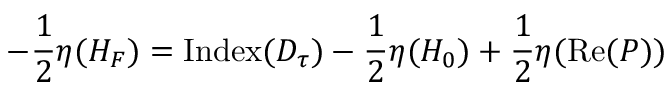<formula> <loc_0><loc_0><loc_500><loc_500>- { \frac { 1 } { 2 } } \eta ( H _ { F } ) = I n d e x ( D _ { \tau } ) - { \frac { 1 } { 2 } } \eta ( H _ { 0 } ) + { \frac { 1 } { 2 } } \eta ( R e ( { P } ) )</formula> 